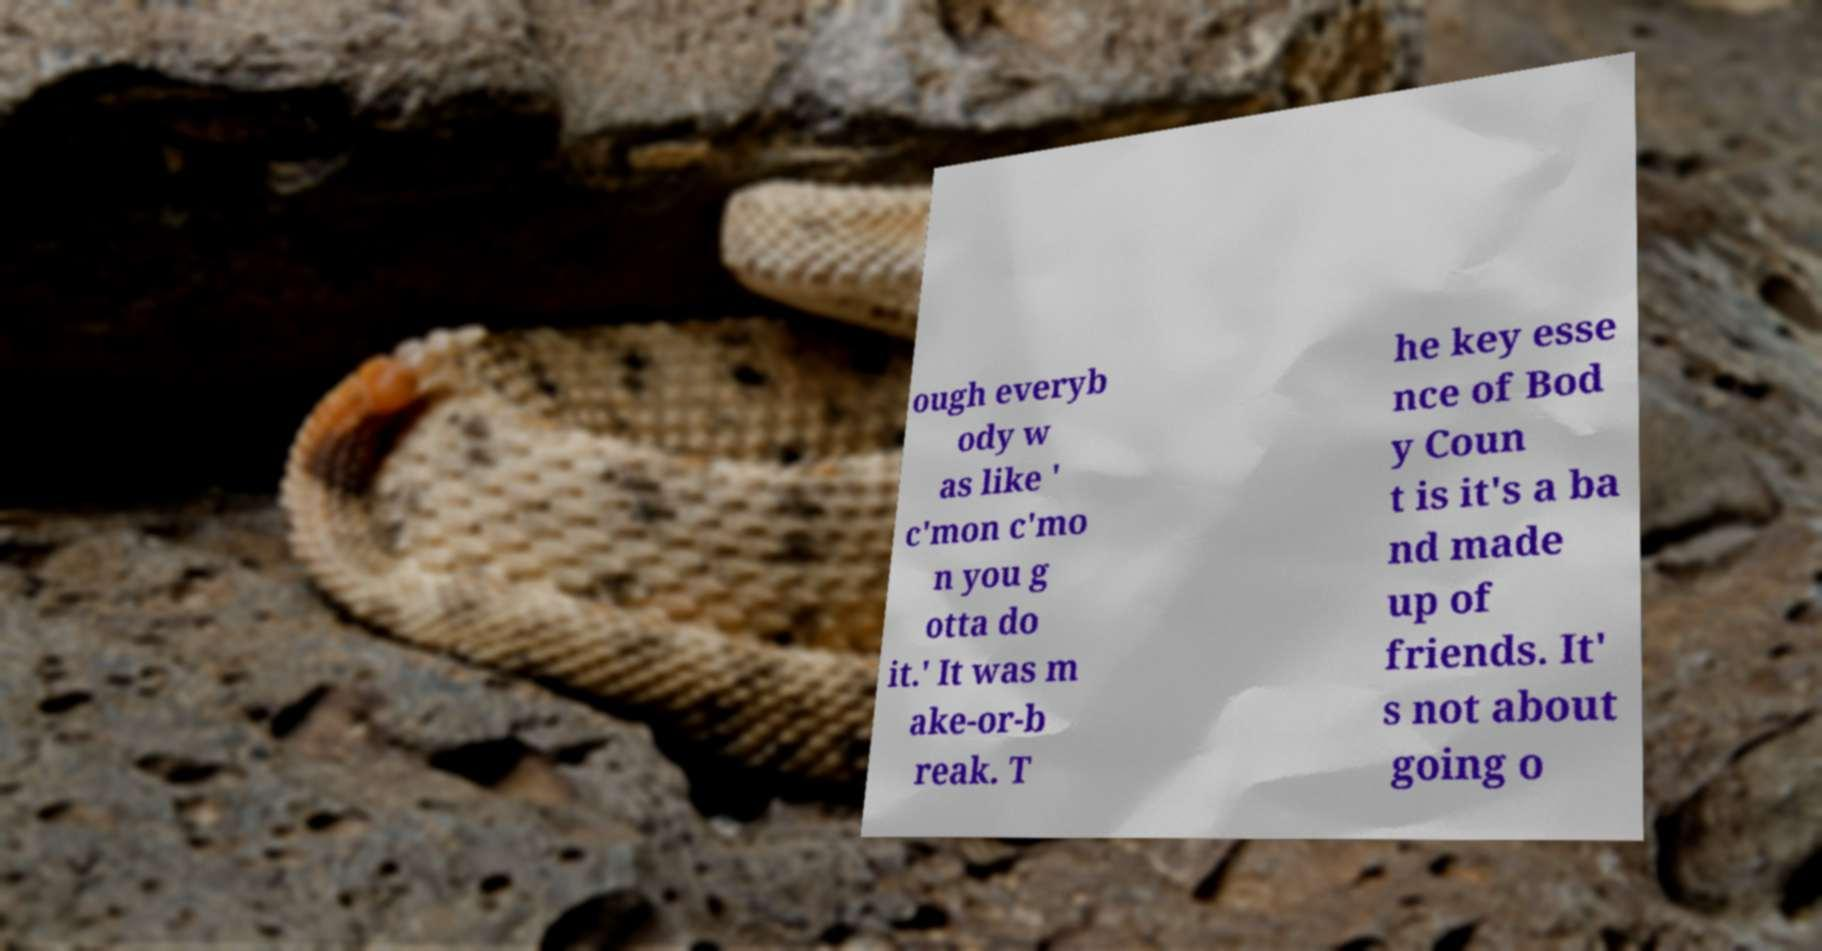Please identify and transcribe the text found in this image. ough everyb ody w as like ' c'mon c'mo n you g otta do it.' It was m ake-or-b reak. T he key esse nce of Bod y Coun t is it's a ba nd made up of friends. It' s not about going o 